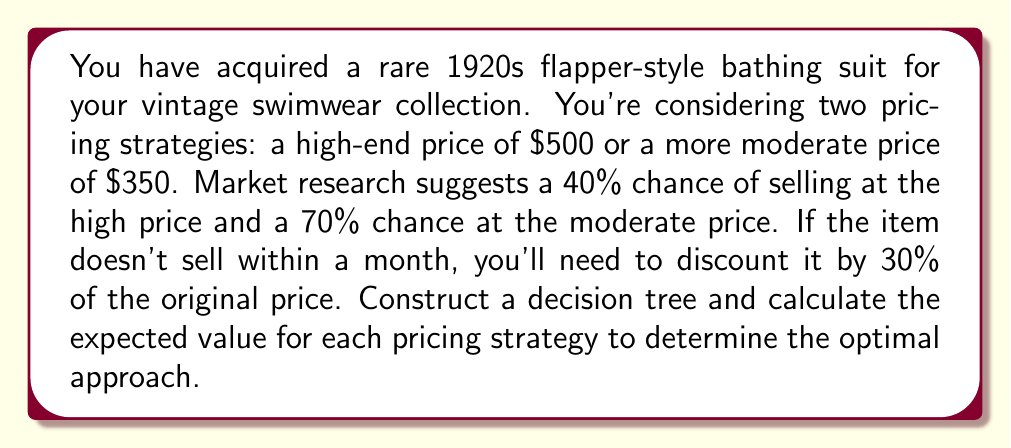Can you answer this question? Let's construct the decision tree and calculate the expected value for each pricing strategy:

1. High-end pricing strategy ($500):
   - Probability of selling: 40% (0.4)
   - Probability of not selling: 60% (0.6)
   - If not sold, discounted price: $500 * (1 - 0.3) = $350

   Expected Value (EV) calculation:
   $$ EV_{high} = 0.4 * 500 + 0.6 * 350 = 200 + 210 = $410 $$

2. Moderate pricing strategy ($350):
   - Probability of selling: 70% (0.7)
   - Probability of not selling: 30% (0.3)
   - If not sold, discounted price: $350 * (1 - 0.3) = $245

   Expected Value (EV) calculation:
   $$ EV_{moderate} = 0.7 * 350 + 0.3 * 245 = 245 + 73.50 = $318.50 $$

Decision tree representation:

[asy]
import geometry;

pair A = (0,0);
pair B1 = (100,50);
pair B2 = (100,-50);
pair C1 = (200,75);
pair C2 = (200,25);
pair C3 = (200,-25);
pair C4 = (200,-75);

draw(A--B1--C1, arrow=Arrow(TeXHead));
draw(A--B1--C2, arrow=Arrow(TeXHead));
draw(A--B2--C3, arrow=Arrow(TeXHead));
draw(A--B2--C4, arrow=Arrow(TeXHead));

label("Start", A, W);
label("$500", (A+B1)/2, N);
label("$350", (A+B2)/2, S);
label("Sell (0.4)", (B1+C1)/2, N);
label("No sell (0.6)", (B1+C2)/2, S);
label("Sell (0.7)", (B2+C3)/2, N);
label("No sell (0.3)", (B2+C4)/2, S);
label("$500", C1, E);
label("$350", C2, E);
label("$350", C3, E);
label("$245", C4, E);

dot(A);
dot(B1);
dot(B2);
dot(C1);
dot(C2);
dot(C3);
dot(C4);
[/asy]

Comparing the expected values:
$$ EV_{high} = $410 > EV_{moderate} = $318.50 $$

Therefore, the optimal pricing strategy is the high-end price of $500, as it yields a higher expected value.
Answer: The optimal pricing strategy is to set the price at $500, which yields an expected value of $410. 